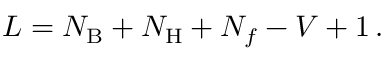<formula> <loc_0><loc_0><loc_500><loc_500>L = N _ { B } + N _ { H } + N _ { f } - V + 1 \, .</formula> 